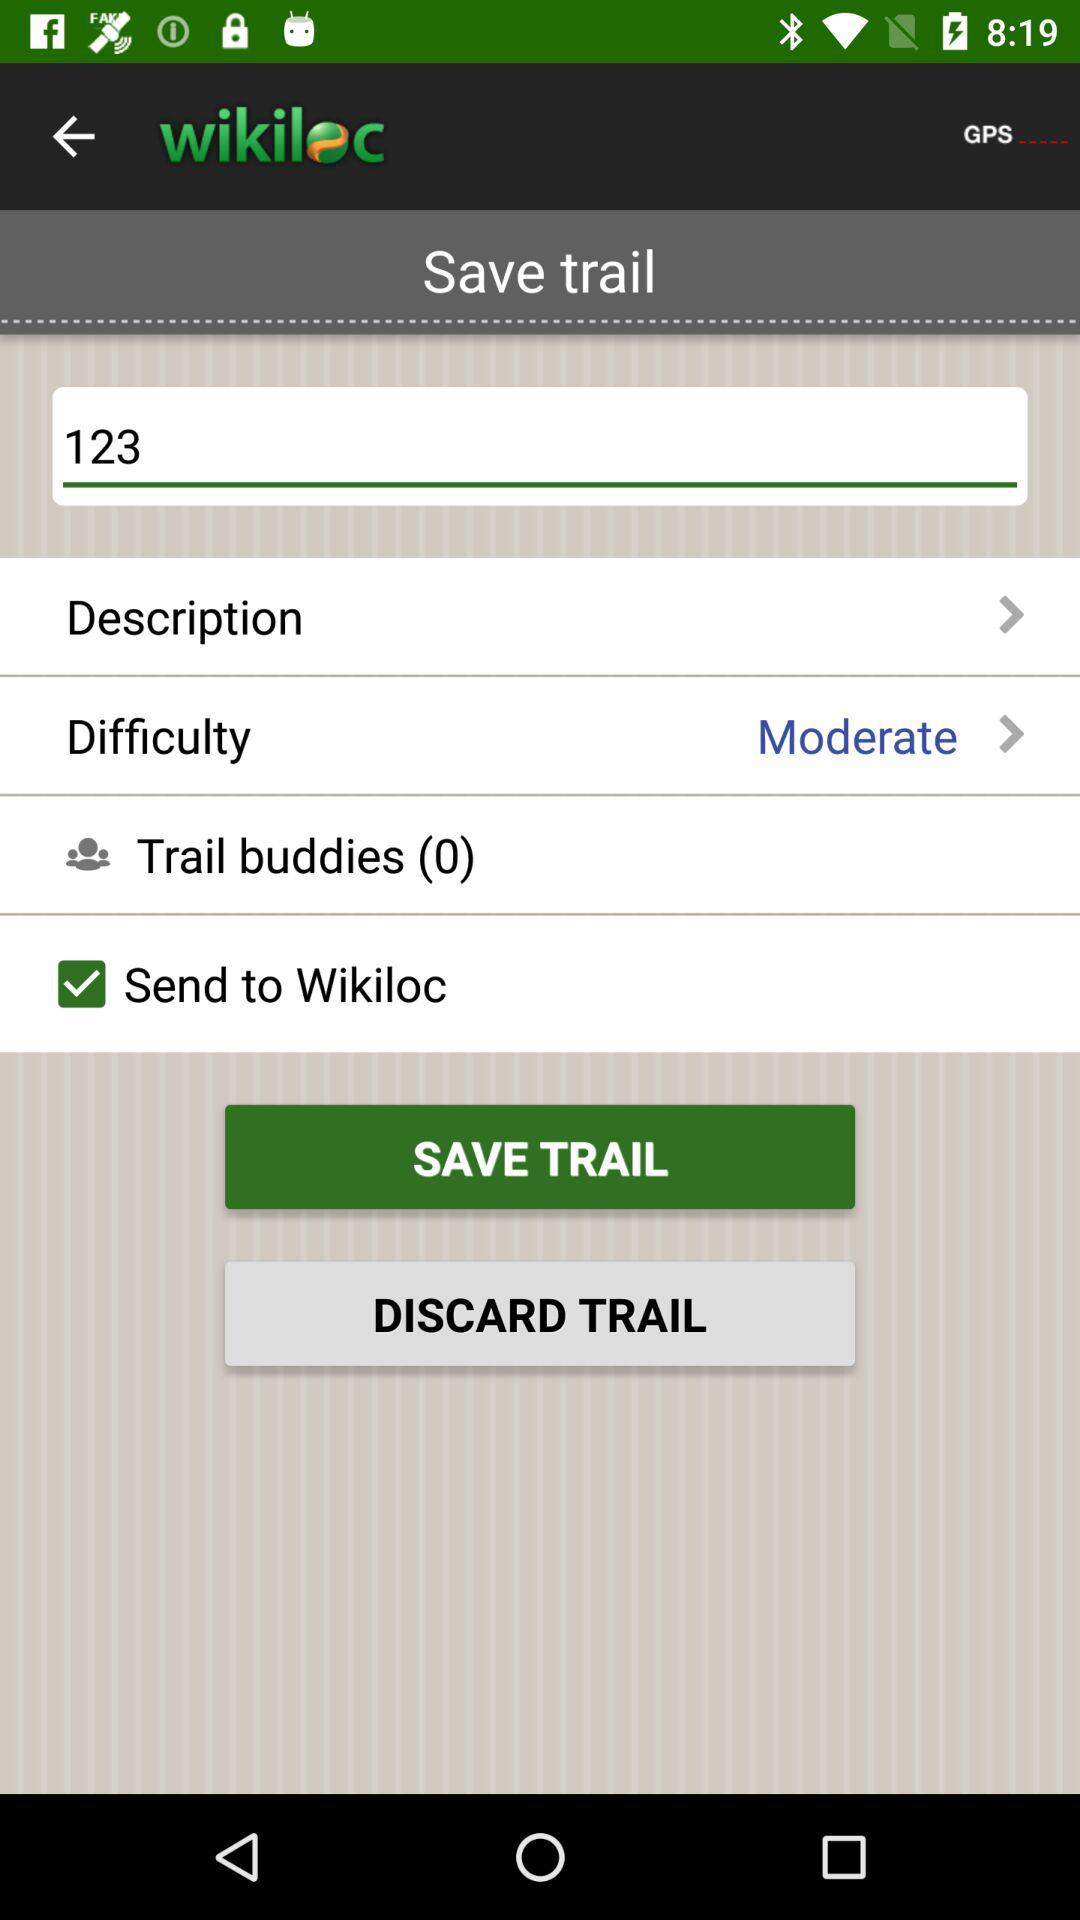What is the application name? The application name is "wikiloc". 